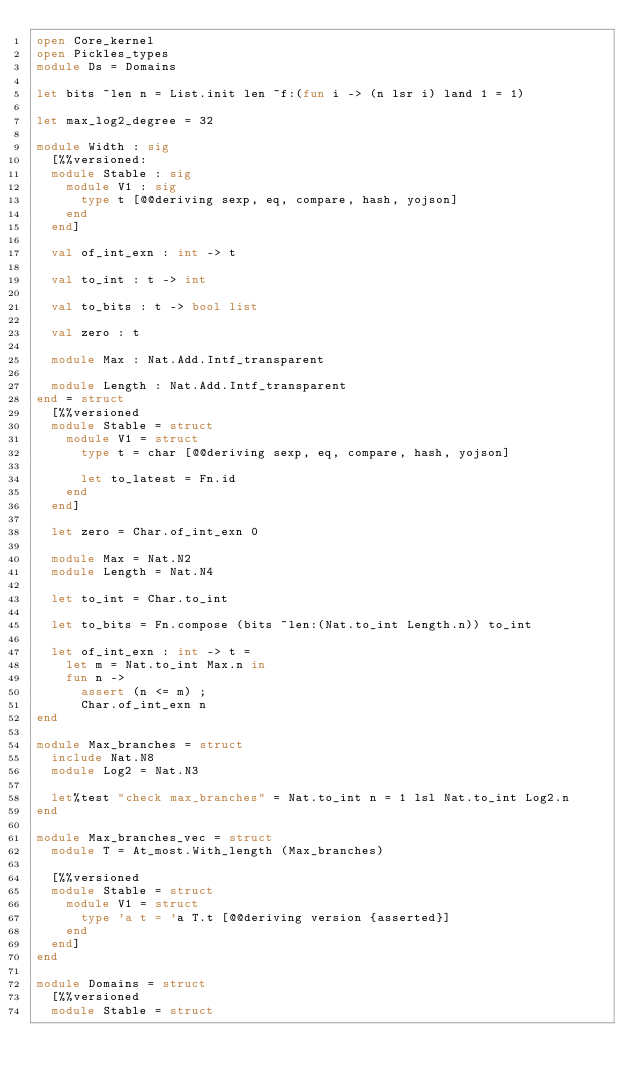<code> <loc_0><loc_0><loc_500><loc_500><_OCaml_>open Core_kernel
open Pickles_types
module Ds = Domains

let bits ~len n = List.init len ~f:(fun i -> (n lsr i) land 1 = 1)

let max_log2_degree = 32

module Width : sig
  [%%versioned:
  module Stable : sig
    module V1 : sig
      type t [@@deriving sexp, eq, compare, hash, yojson]
    end
  end]

  val of_int_exn : int -> t

  val to_int : t -> int

  val to_bits : t -> bool list

  val zero : t

  module Max : Nat.Add.Intf_transparent

  module Length : Nat.Add.Intf_transparent
end = struct
  [%%versioned
  module Stable = struct
    module V1 = struct
      type t = char [@@deriving sexp, eq, compare, hash, yojson]

      let to_latest = Fn.id
    end
  end]

  let zero = Char.of_int_exn 0

  module Max = Nat.N2
  module Length = Nat.N4

  let to_int = Char.to_int

  let to_bits = Fn.compose (bits ~len:(Nat.to_int Length.n)) to_int

  let of_int_exn : int -> t =
    let m = Nat.to_int Max.n in
    fun n ->
      assert (n <= m) ;
      Char.of_int_exn n
end

module Max_branches = struct
  include Nat.N8
  module Log2 = Nat.N3

  let%test "check max_branches" = Nat.to_int n = 1 lsl Nat.to_int Log2.n
end

module Max_branches_vec = struct
  module T = At_most.With_length (Max_branches)

  [%%versioned
  module Stable = struct
    module V1 = struct
      type 'a t = 'a T.t [@@deriving version {asserted}]
    end
  end]
end

module Domains = struct
  [%%versioned
  module Stable = struct</code> 